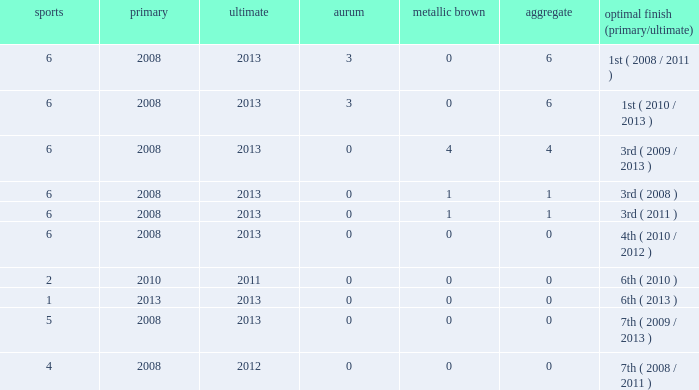What is the fewest number of medals associated with under 6 games and over 0 golds? None. 